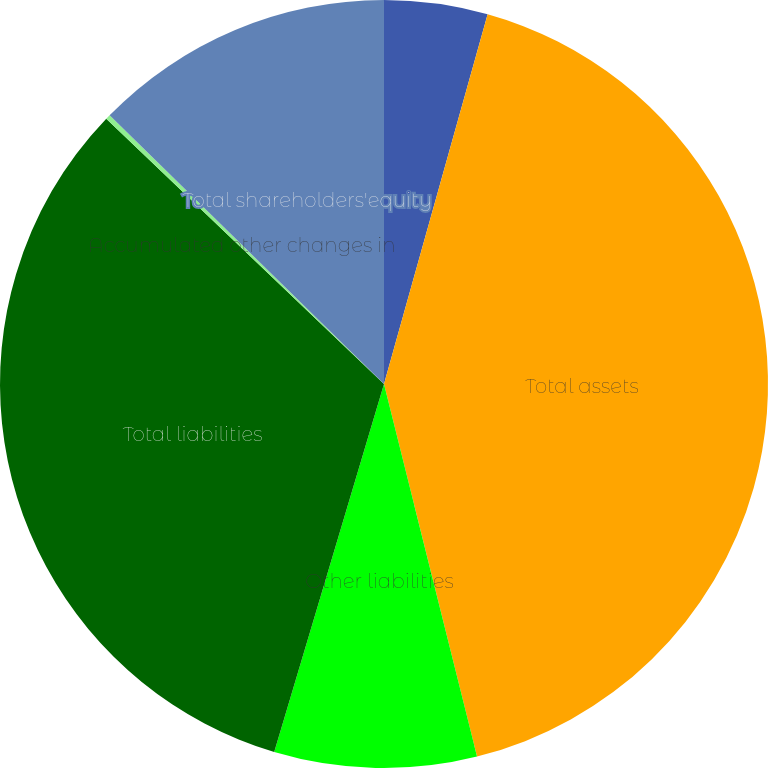<chart> <loc_0><loc_0><loc_500><loc_500><pie_chart><fcel>Other assets<fcel>Total assets<fcel>Other liabilities<fcel>Total liabilities<fcel>Accumulated other changes in<fcel>Total shareholders'equity<nl><fcel>4.35%<fcel>41.76%<fcel>8.51%<fcel>32.52%<fcel>0.2%<fcel>12.67%<nl></chart> 